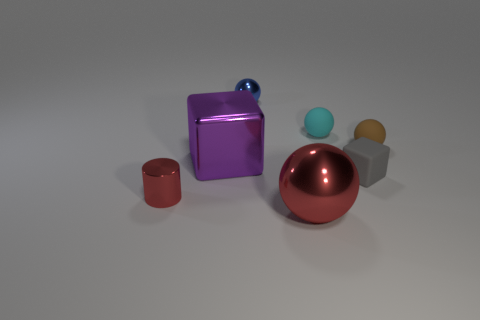Add 1 big yellow metallic balls. How many objects exist? 8 Subtract all cylinders. How many objects are left? 6 Subtract 0 red cubes. How many objects are left? 7 Subtract all red metal cylinders. Subtract all small green shiny things. How many objects are left? 6 Add 7 small shiny things. How many small shiny things are left? 9 Add 6 large spheres. How many large spheres exist? 7 